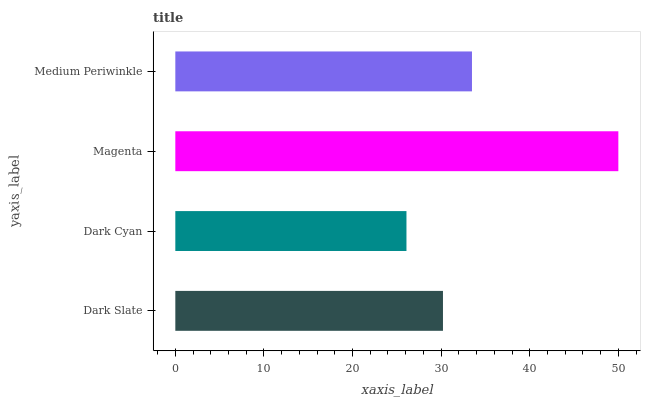Is Dark Cyan the minimum?
Answer yes or no. Yes. Is Magenta the maximum?
Answer yes or no. Yes. Is Magenta the minimum?
Answer yes or no. No. Is Dark Cyan the maximum?
Answer yes or no. No. Is Magenta greater than Dark Cyan?
Answer yes or no. Yes. Is Dark Cyan less than Magenta?
Answer yes or no. Yes. Is Dark Cyan greater than Magenta?
Answer yes or no. No. Is Magenta less than Dark Cyan?
Answer yes or no. No. Is Medium Periwinkle the high median?
Answer yes or no. Yes. Is Dark Slate the low median?
Answer yes or no. Yes. Is Dark Cyan the high median?
Answer yes or no. No. Is Dark Cyan the low median?
Answer yes or no. No. 